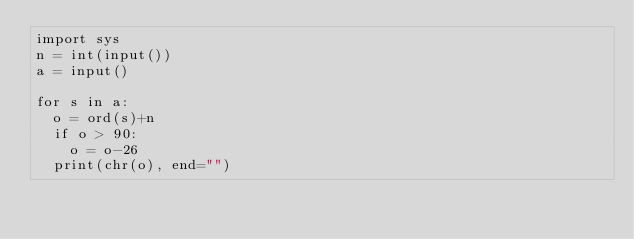<code> <loc_0><loc_0><loc_500><loc_500><_Python_>import sys
n = int(input())
a = input()

for s in a:
  o = ord(s)+n
  if o > 90:
    o = o-26
  print(chr(o), end="")
</code> 